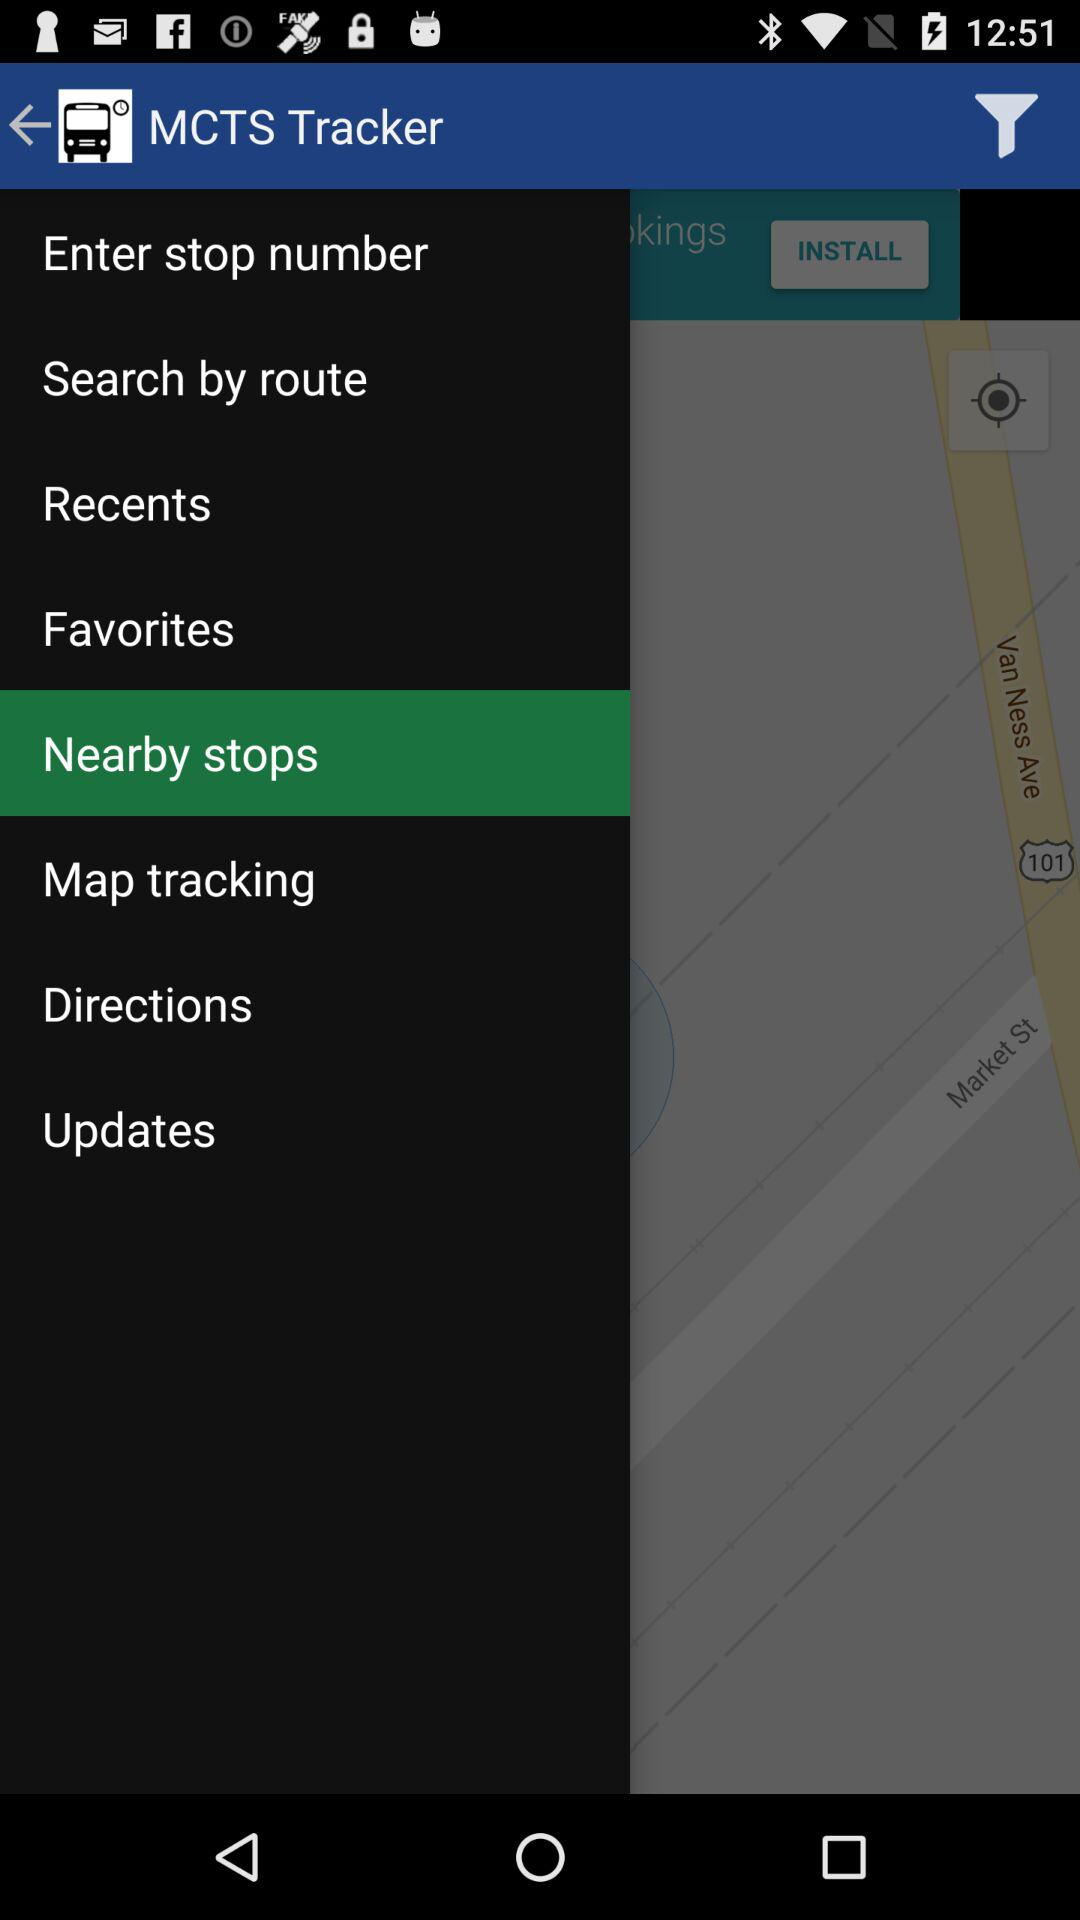What is the application name? The application name is "MCTS Tracker". 